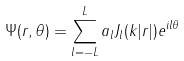<formula> <loc_0><loc_0><loc_500><loc_500>\Psi ( r , \theta ) = \sum _ { l = - L } ^ { L } a _ { l } J _ { l } ( k | r | ) e ^ { i l \theta } \,</formula> 